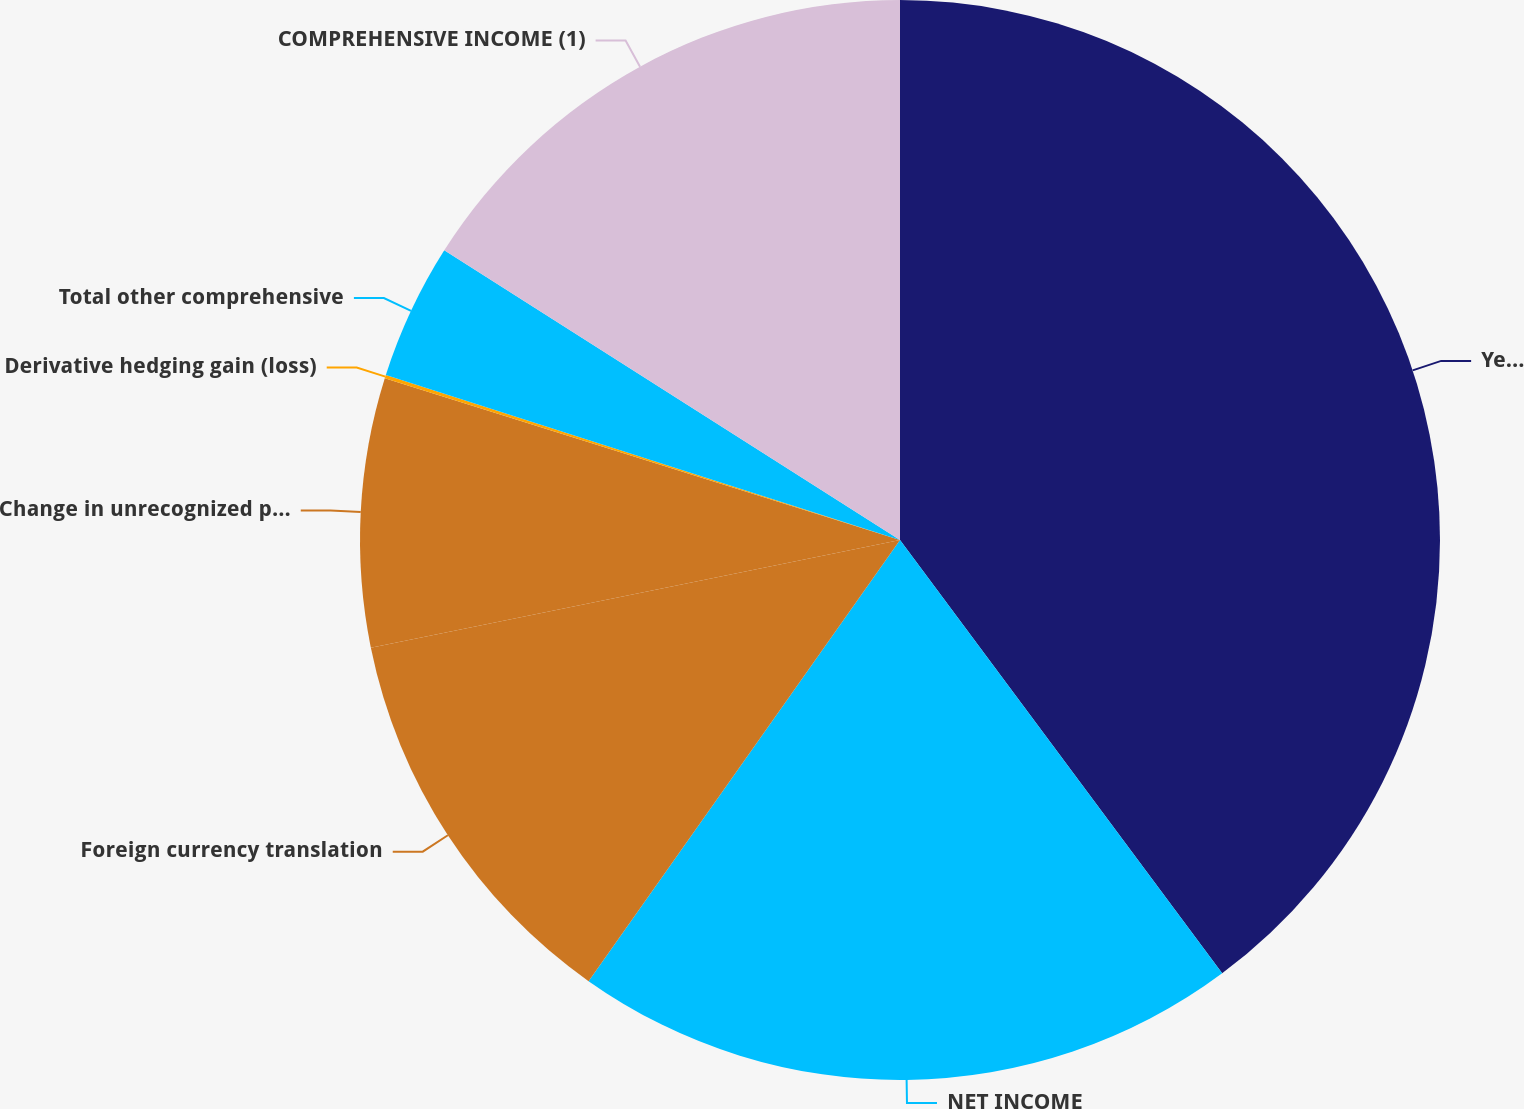<chart> <loc_0><loc_0><loc_500><loc_500><pie_chart><fcel>Year Ended December 31<fcel>NET INCOME<fcel>Foreign currency translation<fcel>Change in unrecognized pension<fcel>Derivative hedging gain (loss)<fcel>Total other comprehensive<fcel>COMPREHENSIVE INCOME (1)<nl><fcel>39.83%<fcel>19.96%<fcel>12.02%<fcel>8.04%<fcel>0.1%<fcel>4.07%<fcel>15.99%<nl></chart> 